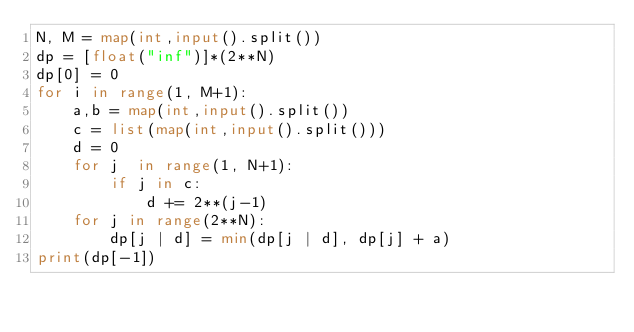Convert code to text. <code><loc_0><loc_0><loc_500><loc_500><_Python_>N, M = map(int,input().split())
dp = [float("inf")]*(2**N)
dp[0] = 0
for i in range(1, M+1):
    a,b = map(int,input().split())
    c = list(map(int,input().split()))
    d = 0
    for j  in range(1, N+1):
        if j in c:
            d += 2**(j-1)
    for j in range(2**N):
        dp[j | d] = min(dp[j | d], dp[j] + a)
print(dp[-1])</code> 